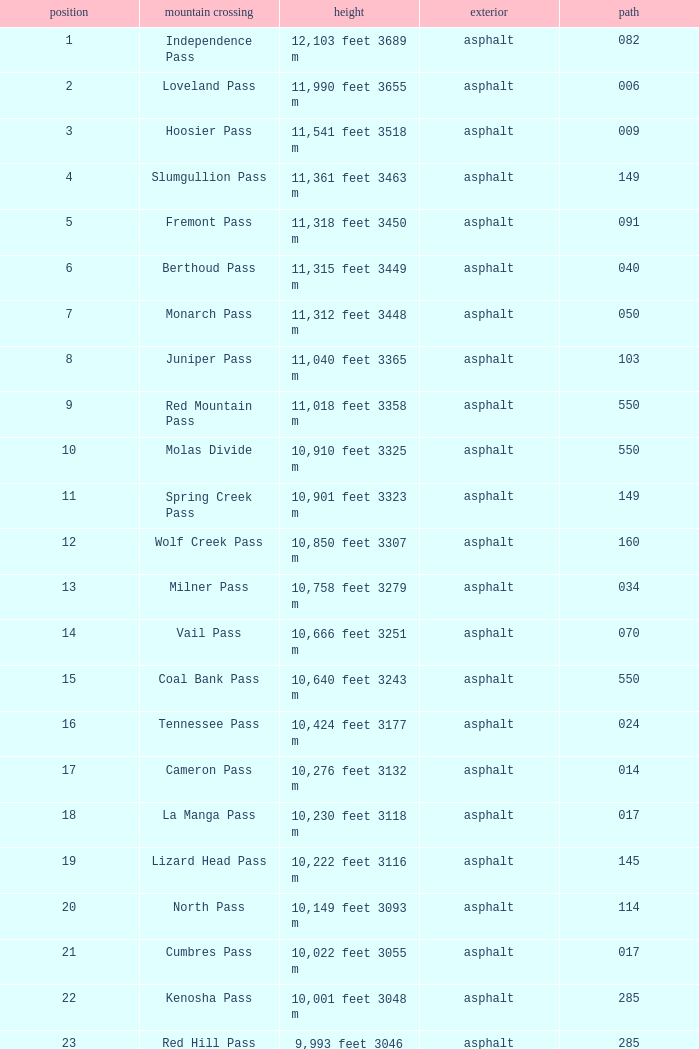What is the Elevation of the mountain on Route 62? 8,970 feet 2734 m. 